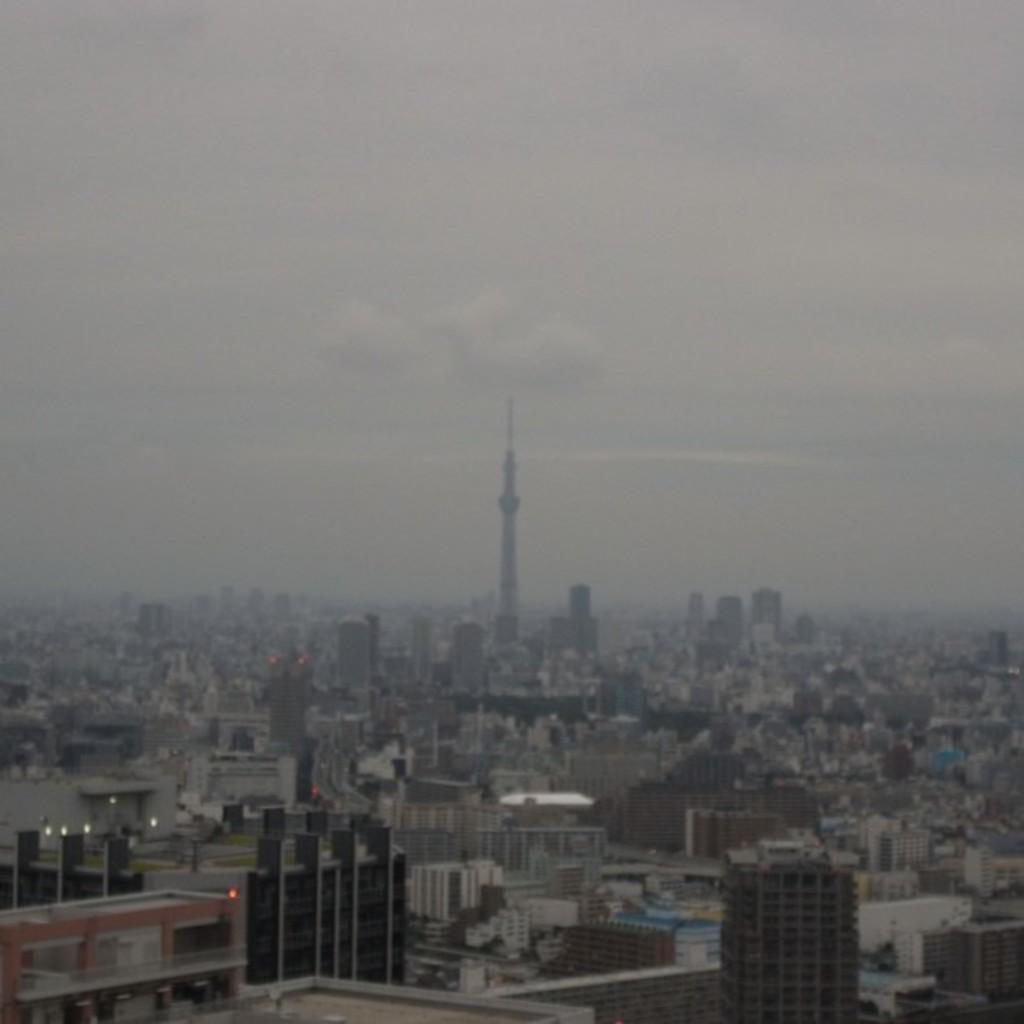How would you summarize this image in a sentence or two? In this picture we can observe some buildings. There is a tall tower. In the background there is a sky with some clouds. 